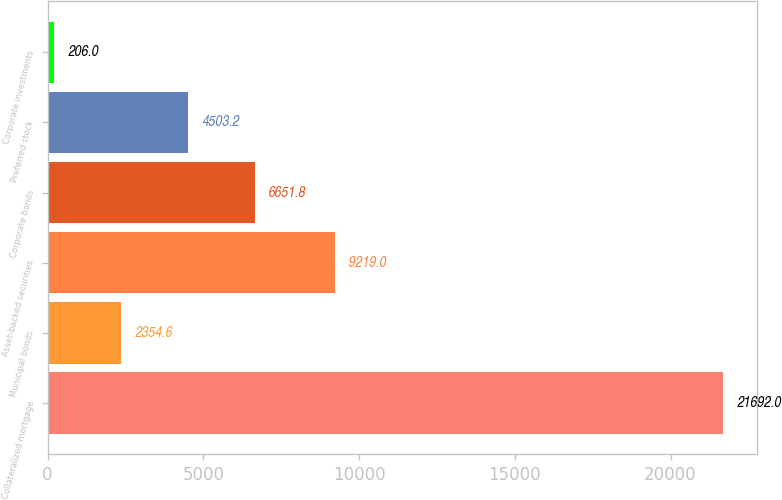<chart> <loc_0><loc_0><loc_500><loc_500><bar_chart><fcel>Collateralized mortgage<fcel>Municipal bonds<fcel>Asset-backed securities<fcel>Corporate bonds<fcel>Preferred stock<fcel>Corporate investments<nl><fcel>21692<fcel>2354.6<fcel>9219<fcel>6651.8<fcel>4503.2<fcel>206<nl></chart> 